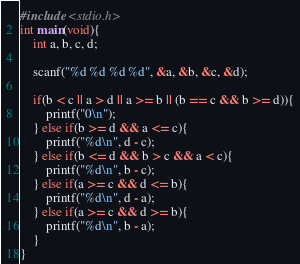Convert code to text. <code><loc_0><loc_0><loc_500><loc_500><_C_>#include <stdio.h>
int main(void){
    int a, b, c, d;
    
    scanf("%d %d %d %d", &a, &b, &c, &d);
    
    if(b < c || a > d || a >= b || (b == c && b >= d)){
        printf("0\n");
    } else if(b >= d && a <= c){
        printf("%d\n", d - c);
    } else if(b <= d && b > c && a < c){
        printf("%d\n", b - c);
    } else if(a >= c && d <= b){
        printf("%d\n", d - a);
    } else if(a >= c && d >= b){
        printf("%d\n", b - a);
    }
}
</code> 